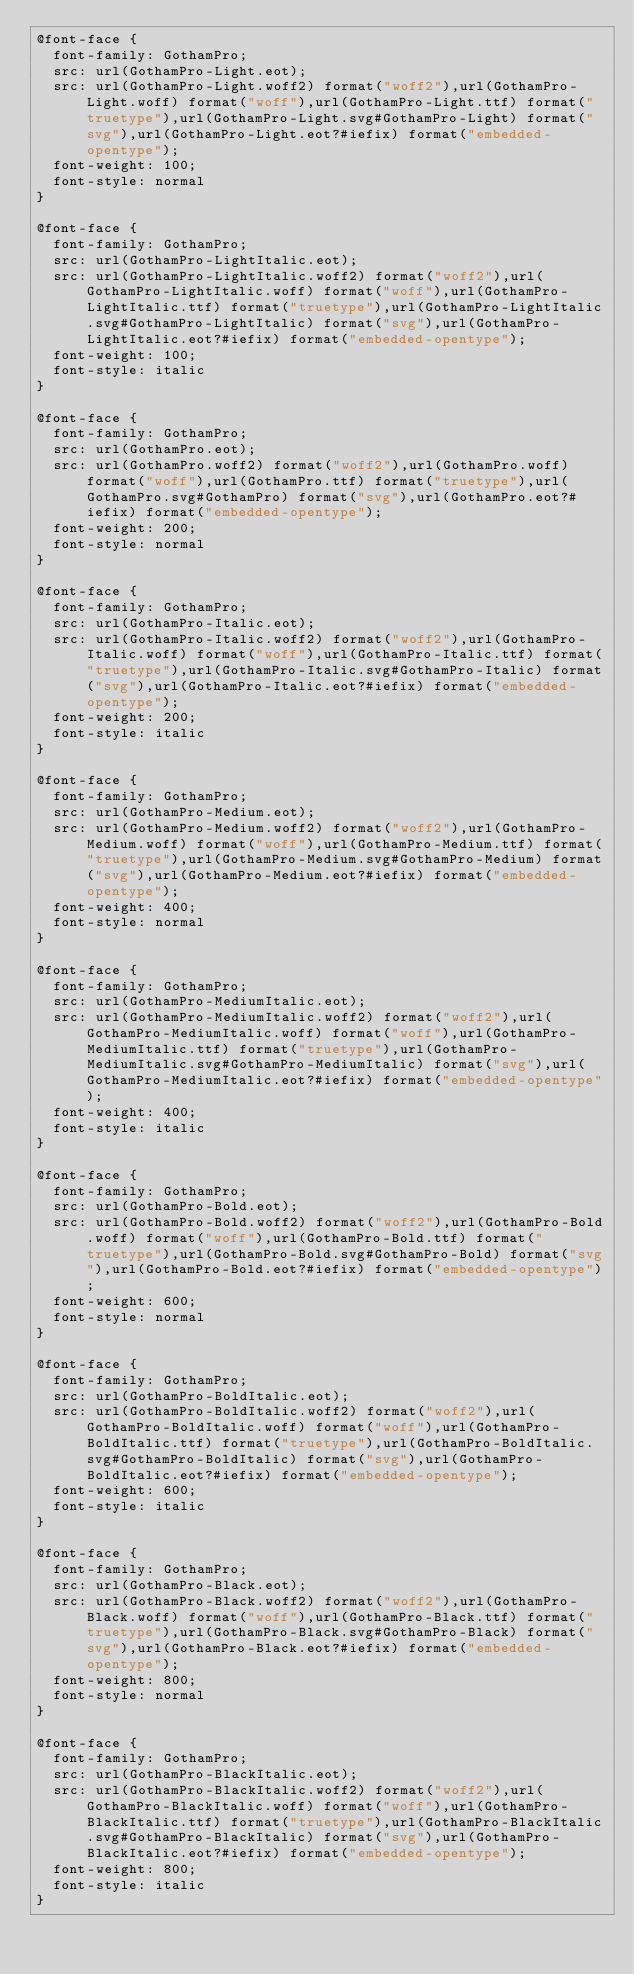<code> <loc_0><loc_0><loc_500><loc_500><_CSS_>@font-face {
  font-family: GothamPro;
  src: url(GothamPro-Light.eot);
  src: url(GothamPro-Light.woff2) format("woff2"),url(GothamPro-Light.woff) format("woff"),url(GothamPro-Light.ttf) format("truetype"),url(GothamPro-Light.svg#GothamPro-Light) format("svg"),url(GothamPro-Light.eot?#iefix) format("embedded-opentype");
  font-weight: 100;
  font-style: normal
}

@font-face {
  font-family: GothamPro;
  src: url(GothamPro-LightItalic.eot);
  src: url(GothamPro-LightItalic.woff2) format("woff2"),url(GothamPro-LightItalic.woff) format("woff"),url(GothamPro-LightItalic.ttf) format("truetype"),url(GothamPro-LightItalic.svg#GothamPro-LightItalic) format("svg"),url(GothamPro-LightItalic.eot?#iefix) format("embedded-opentype");
  font-weight: 100;
  font-style: italic
}

@font-face {
  font-family: GothamPro;
  src: url(GothamPro.eot);
  src: url(GothamPro.woff2) format("woff2"),url(GothamPro.woff) format("woff"),url(GothamPro.ttf) format("truetype"),url(GothamPro.svg#GothamPro) format("svg"),url(GothamPro.eot?#iefix) format("embedded-opentype");
  font-weight: 200;
  font-style: normal
}

@font-face {
  font-family: GothamPro;
  src: url(GothamPro-Italic.eot);
  src: url(GothamPro-Italic.woff2) format("woff2"),url(GothamPro-Italic.woff) format("woff"),url(GothamPro-Italic.ttf) format("truetype"),url(GothamPro-Italic.svg#GothamPro-Italic) format("svg"),url(GothamPro-Italic.eot?#iefix) format("embedded-opentype");
  font-weight: 200;
  font-style: italic
}

@font-face {
  font-family: GothamPro;
  src: url(GothamPro-Medium.eot);
  src: url(GothamPro-Medium.woff2) format("woff2"),url(GothamPro-Medium.woff) format("woff"),url(GothamPro-Medium.ttf) format("truetype"),url(GothamPro-Medium.svg#GothamPro-Medium) format("svg"),url(GothamPro-Medium.eot?#iefix) format("embedded-opentype");
  font-weight: 400;
  font-style: normal
}

@font-face {
  font-family: GothamPro;
  src: url(GothamPro-MediumItalic.eot);
  src: url(GothamPro-MediumItalic.woff2) format("woff2"),url(GothamPro-MediumItalic.woff) format("woff"),url(GothamPro-MediumItalic.ttf) format("truetype"),url(GothamPro-MediumItalic.svg#GothamPro-MediumItalic) format("svg"),url(GothamPro-MediumItalic.eot?#iefix) format("embedded-opentype");
  font-weight: 400;
  font-style: italic
}

@font-face {
  font-family: GothamPro;
  src: url(GothamPro-Bold.eot);
  src: url(GothamPro-Bold.woff2) format("woff2"),url(GothamPro-Bold.woff) format("woff"),url(GothamPro-Bold.ttf) format("truetype"),url(GothamPro-Bold.svg#GothamPro-Bold) format("svg"),url(GothamPro-Bold.eot?#iefix) format("embedded-opentype");
  font-weight: 600;
  font-style: normal
}

@font-face {
  font-family: GothamPro;
  src: url(GothamPro-BoldItalic.eot);
  src: url(GothamPro-BoldItalic.woff2) format("woff2"),url(GothamPro-BoldItalic.woff) format("woff"),url(GothamPro-BoldItalic.ttf) format("truetype"),url(GothamPro-BoldItalic.svg#GothamPro-BoldItalic) format("svg"),url(GothamPro-BoldItalic.eot?#iefix) format("embedded-opentype");
  font-weight: 600;
  font-style: italic
}

@font-face {
  font-family: GothamPro;
  src: url(GothamPro-Black.eot);
  src: url(GothamPro-Black.woff2) format("woff2"),url(GothamPro-Black.woff) format("woff"),url(GothamPro-Black.ttf) format("truetype"),url(GothamPro-Black.svg#GothamPro-Black) format("svg"),url(GothamPro-Black.eot?#iefix) format("embedded-opentype");
  font-weight: 800;
  font-style: normal
}

@font-face {
  font-family: GothamPro;
  src: url(GothamPro-BlackItalic.eot);
  src: url(GothamPro-BlackItalic.woff2) format("woff2"),url(GothamPro-BlackItalic.woff) format("woff"),url(GothamPro-BlackItalic.ttf) format("truetype"),url(GothamPro-BlackItalic.svg#GothamPro-BlackItalic) format("svg"),url(GothamPro-BlackItalic.eot?#iefix) format("embedded-opentype");
  font-weight: 800;
  font-style: italic
}
</code> 